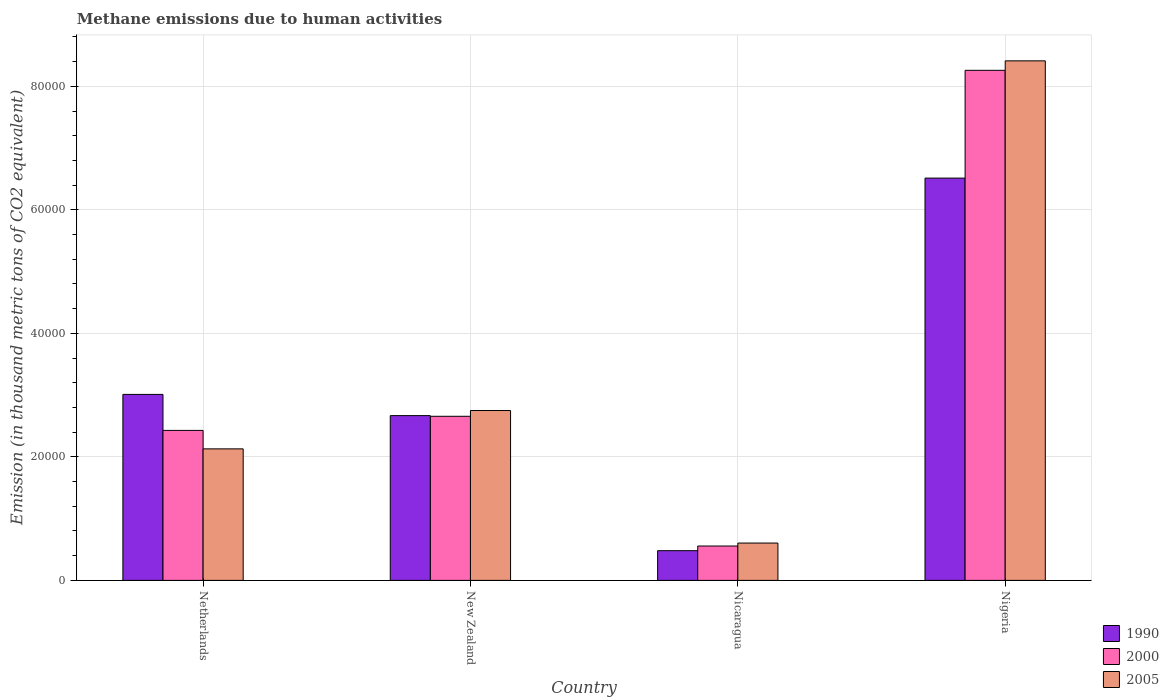How many different coloured bars are there?
Give a very brief answer. 3. What is the label of the 3rd group of bars from the left?
Your answer should be very brief. Nicaragua. What is the amount of methane emitted in 2000 in Nicaragua?
Your response must be concise. 5565.7. Across all countries, what is the maximum amount of methane emitted in 2005?
Provide a short and direct response. 8.41e+04. Across all countries, what is the minimum amount of methane emitted in 2000?
Ensure brevity in your answer.  5565.7. In which country was the amount of methane emitted in 2000 maximum?
Your response must be concise. Nigeria. In which country was the amount of methane emitted in 1990 minimum?
Offer a very short reply. Nicaragua. What is the total amount of methane emitted in 2000 in the graph?
Ensure brevity in your answer.  1.39e+05. What is the difference between the amount of methane emitted in 2000 in Netherlands and that in New Zealand?
Offer a very short reply. -2283.5. What is the difference between the amount of methane emitted in 2000 in Netherlands and the amount of methane emitted in 1990 in New Zealand?
Keep it short and to the point. -2394.1. What is the average amount of methane emitted in 1990 per country?
Your response must be concise. 3.17e+04. What is the difference between the amount of methane emitted of/in 2005 and amount of methane emitted of/in 1990 in New Zealand?
Provide a succinct answer. 824. What is the ratio of the amount of methane emitted in 2005 in New Zealand to that in Nigeria?
Provide a short and direct response. 0.33. Is the amount of methane emitted in 1990 in Netherlands less than that in New Zealand?
Your answer should be compact. No. What is the difference between the highest and the second highest amount of methane emitted in 1990?
Provide a succinct answer. -3.85e+04. What is the difference between the highest and the lowest amount of methane emitted in 2005?
Your answer should be very brief. 7.81e+04. In how many countries, is the amount of methane emitted in 2005 greater than the average amount of methane emitted in 2005 taken over all countries?
Your response must be concise. 1. Is the sum of the amount of methane emitted in 1990 in New Zealand and Nicaragua greater than the maximum amount of methane emitted in 2005 across all countries?
Your response must be concise. No. What does the 1st bar from the left in Nigeria represents?
Provide a succinct answer. 1990. Is it the case that in every country, the sum of the amount of methane emitted in 1990 and amount of methane emitted in 2000 is greater than the amount of methane emitted in 2005?
Ensure brevity in your answer.  Yes. How many bars are there?
Offer a very short reply. 12. How many countries are there in the graph?
Ensure brevity in your answer.  4. Does the graph contain any zero values?
Your response must be concise. No. Does the graph contain grids?
Ensure brevity in your answer.  Yes. How many legend labels are there?
Offer a terse response. 3. How are the legend labels stacked?
Give a very brief answer. Vertical. What is the title of the graph?
Ensure brevity in your answer.  Methane emissions due to human activities. What is the label or title of the Y-axis?
Ensure brevity in your answer.  Emission (in thousand metric tons of CO2 equivalent). What is the Emission (in thousand metric tons of CO2 equivalent) of 1990 in Netherlands?
Your answer should be compact. 3.01e+04. What is the Emission (in thousand metric tons of CO2 equivalent) of 2000 in Netherlands?
Give a very brief answer. 2.43e+04. What is the Emission (in thousand metric tons of CO2 equivalent) of 2005 in Netherlands?
Your answer should be compact. 2.13e+04. What is the Emission (in thousand metric tons of CO2 equivalent) in 1990 in New Zealand?
Provide a short and direct response. 2.67e+04. What is the Emission (in thousand metric tons of CO2 equivalent) of 2000 in New Zealand?
Ensure brevity in your answer.  2.66e+04. What is the Emission (in thousand metric tons of CO2 equivalent) in 2005 in New Zealand?
Keep it short and to the point. 2.75e+04. What is the Emission (in thousand metric tons of CO2 equivalent) in 1990 in Nicaragua?
Provide a short and direct response. 4811.3. What is the Emission (in thousand metric tons of CO2 equivalent) of 2000 in Nicaragua?
Your answer should be very brief. 5565.7. What is the Emission (in thousand metric tons of CO2 equivalent) in 2005 in Nicaragua?
Keep it short and to the point. 6045. What is the Emission (in thousand metric tons of CO2 equivalent) of 1990 in Nigeria?
Ensure brevity in your answer.  6.51e+04. What is the Emission (in thousand metric tons of CO2 equivalent) in 2000 in Nigeria?
Your response must be concise. 8.26e+04. What is the Emission (in thousand metric tons of CO2 equivalent) in 2005 in Nigeria?
Offer a very short reply. 8.41e+04. Across all countries, what is the maximum Emission (in thousand metric tons of CO2 equivalent) of 1990?
Provide a succinct answer. 6.51e+04. Across all countries, what is the maximum Emission (in thousand metric tons of CO2 equivalent) in 2000?
Keep it short and to the point. 8.26e+04. Across all countries, what is the maximum Emission (in thousand metric tons of CO2 equivalent) in 2005?
Make the answer very short. 8.41e+04. Across all countries, what is the minimum Emission (in thousand metric tons of CO2 equivalent) in 1990?
Provide a succinct answer. 4811.3. Across all countries, what is the minimum Emission (in thousand metric tons of CO2 equivalent) in 2000?
Provide a short and direct response. 5565.7. Across all countries, what is the minimum Emission (in thousand metric tons of CO2 equivalent) in 2005?
Ensure brevity in your answer.  6045. What is the total Emission (in thousand metric tons of CO2 equivalent) in 1990 in the graph?
Provide a short and direct response. 1.27e+05. What is the total Emission (in thousand metric tons of CO2 equivalent) of 2000 in the graph?
Ensure brevity in your answer.  1.39e+05. What is the total Emission (in thousand metric tons of CO2 equivalent) of 2005 in the graph?
Make the answer very short. 1.39e+05. What is the difference between the Emission (in thousand metric tons of CO2 equivalent) in 1990 in Netherlands and that in New Zealand?
Offer a terse response. 3434.2. What is the difference between the Emission (in thousand metric tons of CO2 equivalent) in 2000 in Netherlands and that in New Zealand?
Offer a very short reply. -2283.5. What is the difference between the Emission (in thousand metric tons of CO2 equivalent) in 2005 in Netherlands and that in New Zealand?
Your response must be concise. -6208.4. What is the difference between the Emission (in thousand metric tons of CO2 equivalent) of 1990 in Netherlands and that in Nicaragua?
Keep it short and to the point. 2.53e+04. What is the difference between the Emission (in thousand metric tons of CO2 equivalent) in 2000 in Netherlands and that in Nicaragua?
Give a very brief answer. 1.87e+04. What is the difference between the Emission (in thousand metric tons of CO2 equivalent) in 2005 in Netherlands and that in Nicaragua?
Provide a succinct answer. 1.53e+04. What is the difference between the Emission (in thousand metric tons of CO2 equivalent) in 1990 in Netherlands and that in Nigeria?
Your answer should be very brief. -3.50e+04. What is the difference between the Emission (in thousand metric tons of CO2 equivalent) of 2000 in Netherlands and that in Nigeria?
Your response must be concise. -5.83e+04. What is the difference between the Emission (in thousand metric tons of CO2 equivalent) of 2005 in Netherlands and that in Nigeria?
Offer a terse response. -6.28e+04. What is the difference between the Emission (in thousand metric tons of CO2 equivalent) in 1990 in New Zealand and that in Nicaragua?
Keep it short and to the point. 2.19e+04. What is the difference between the Emission (in thousand metric tons of CO2 equivalent) in 2000 in New Zealand and that in Nicaragua?
Offer a terse response. 2.10e+04. What is the difference between the Emission (in thousand metric tons of CO2 equivalent) of 2005 in New Zealand and that in Nicaragua?
Offer a very short reply. 2.15e+04. What is the difference between the Emission (in thousand metric tons of CO2 equivalent) of 1990 in New Zealand and that in Nigeria?
Give a very brief answer. -3.85e+04. What is the difference between the Emission (in thousand metric tons of CO2 equivalent) in 2000 in New Zealand and that in Nigeria?
Your answer should be compact. -5.60e+04. What is the difference between the Emission (in thousand metric tons of CO2 equivalent) of 2005 in New Zealand and that in Nigeria?
Offer a very short reply. -5.66e+04. What is the difference between the Emission (in thousand metric tons of CO2 equivalent) of 1990 in Nicaragua and that in Nigeria?
Your response must be concise. -6.03e+04. What is the difference between the Emission (in thousand metric tons of CO2 equivalent) of 2000 in Nicaragua and that in Nigeria?
Provide a succinct answer. -7.70e+04. What is the difference between the Emission (in thousand metric tons of CO2 equivalent) in 2005 in Nicaragua and that in Nigeria?
Offer a very short reply. -7.81e+04. What is the difference between the Emission (in thousand metric tons of CO2 equivalent) of 1990 in Netherlands and the Emission (in thousand metric tons of CO2 equivalent) of 2000 in New Zealand?
Ensure brevity in your answer.  3544.8. What is the difference between the Emission (in thousand metric tons of CO2 equivalent) of 1990 in Netherlands and the Emission (in thousand metric tons of CO2 equivalent) of 2005 in New Zealand?
Offer a very short reply. 2610.2. What is the difference between the Emission (in thousand metric tons of CO2 equivalent) of 2000 in Netherlands and the Emission (in thousand metric tons of CO2 equivalent) of 2005 in New Zealand?
Offer a very short reply. -3218.1. What is the difference between the Emission (in thousand metric tons of CO2 equivalent) of 1990 in Netherlands and the Emission (in thousand metric tons of CO2 equivalent) of 2000 in Nicaragua?
Your response must be concise. 2.45e+04. What is the difference between the Emission (in thousand metric tons of CO2 equivalent) in 1990 in Netherlands and the Emission (in thousand metric tons of CO2 equivalent) in 2005 in Nicaragua?
Your answer should be very brief. 2.41e+04. What is the difference between the Emission (in thousand metric tons of CO2 equivalent) of 2000 in Netherlands and the Emission (in thousand metric tons of CO2 equivalent) of 2005 in Nicaragua?
Offer a very short reply. 1.82e+04. What is the difference between the Emission (in thousand metric tons of CO2 equivalent) of 1990 in Netherlands and the Emission (in thousand metric tons of CO2 equivalent) of 2000 in Nigeria?
Provide a succinct answer. -5.25e+04. What is the difference between the Emission (in thousand metric tons of CO2 equivalent) of 1990 in Netherlands and the Emission (in thousand metric tons of CO2 equivalent) of 2005 in Nigeria?
Offer a terse response. -5.40e+04. What is the difference between the Emission (in thousand metric tons of CO2 equivalent) of 2000 in Netherlands and the Emission (in thousand metric tons of CO2 equivalent) of 2005 in Nigeria?
Make the answer very short. -5.98e+04. What is the difference between the Emission (in thousand metric tons of CO2 equivalent) in 1990 in New Zealand and the Emission (in thousand metric tons of CO2 equivalent) in 2000 in Nicaragua?
Ensure brevity in your answer.  2.11e+04. What is the difference between the Emission (in thousand metric tons of CO2 equivalent) of 1990 in New Zealand and the Emission (in thousand metric tons of CO2 equivalent) of 2005 in Nicaragua?
Provide a short and direct response. 2.06e+04. What is the difference between the Emission (in thousand metric tons of CO2 equivalent) in 2000 in New Zealand and the Emission (in thousand metric tons of CO2 equivalent) in 2005 in Nicaragua?
Keep it short and to the point. 2.05e+04. What is the difference between the Emission (in thousand metric tons of CO2 equivalent) in 1990 in New Zealand and the Emission (in thousand metric tons of CO2 equivalent) in 2000 in Nigeria?
Make the answer very short. -5.59e+04. What is the difference between the Emission (in thousand metric tons of CO2 equivalent) in 1990 in New Zealand and the Emission (in thousand metric tons of CO2 equivalent) in 2005 in Nigeria?
Your response must be concise. -5.74e+04. What is the difference between the Emission (in thousand metric tons of CO2 equivalent) of 2000 in New Zealand and the Emission (in thousand metric tons of CO2 equivalent) of 2005 in Nigeria?
Make the answer very short. -5.76e+04. What is the difference between the Emission (in thousand metric tons of CO2 equivalent) in 1990 in Nicaragua and the Emission (in thousand metric tons of CO2 equivalent) in 2000 in Nigeria?
Ensure brevity in your answer.  -7.78e+04. What is the difference between the Emission (in thousand metric tons of CO2 equivalent) of 1990 in Nicaragua and the Emission (in thousand metric tons of CO2 equivalent) of 2005 in Nigeria?
Your response must be concise. -7.93e+04. What is the difference between the Emission (in thousand metric tons of CO2 equivalent) of 2000 in Nicaragua and the Emission (in thousand metric tons of CO2 equivalent) of 2005 in Nigeria?
Give a very brief answer. -7.86e+04. What is the average Emission (in thousand metric tons of CO2 equivalent) in 1990 per country?
Your answer should be very brief. 3.17e+04. What is the average Emission (in thousand metric tons of CO2 equivalent) of 2000 per country?
Provide a short and direct response. 3.48e+04. What is the average Emission (in thousand metric tons of CO2 equivalent) in 2005 per country?
Make the answer very short. 3.47e+04. What is the difference between the Emission (in thousand metric tons of CO2 equivalent) of 1990 and Emission (in thousand metric tons of CO2 equivalent) of 2000 in Netherlands?
Ensure brevity in your answer.  5828.3. What is the difference between the Emission (in thousand metric tons of CO2 equivalent) in 1990 and Emission (in thousand metric tons of CO2 equivalent) in 2005 in Netherlands?
Your response must be concise. 8818.6. What is the difference between the Emission (in thousand metric tons of CO2 equivalent) in 2000 and Emission (in thousand metric tons of CO2 equivalent) in 2005 in Netherlands?
Provide a succinct answer. 2990.3. What is the difference between the Emission (in thousand metric tons of CO2 equivalent) in 1990 and Emission (in thousand metric tons of CO2 equivalent) in 2000 in New Zealand?
Offer a very short reply. 110.6. What is the difference between the Emission (in thousand metric tons of CO2 equivalent) in 1990 and Emission (in thousand metric tons of CO2 equivalent) in 2005 in New Zealand?
Provide a short and direct response. -824. What is the difference between the Emission (in thousand metric tons of CO2 equivalent) of 2000 and Emission (in thousand metric tons of CO2 equivalent) of 2005 in New Zealand?
Keep it short and to the point. -934.6. What is the difference between the Emission (in thousand metric tons of CO2 equivalent) of 1990 and Emission (in thousand metric tons of CO2 equivalent) of 2000 in Nicaragua?
Offer a terse response. -754.4. What is the difference between the Emission (in thousand metric tons of CO2 equivalent) of 1990 and Emission (in thousand metric tons of CO2 equivalent) of 2005 in Nicaragua?
Make the answer very short. -1233.7. What is the difference between the Emission (in thousand metric tons of CO2 equivalent) in 2000 and Emission (in thousand metric tons of CO2 equivalent) in 2005 in Nicaragua?
Make the answer very short. -479.3. What is the difference between the Emission (in thousand metric tons of CO2 equivalent) of 1990 and Emission (in thousand metric tons of CO2 equivalent) of 2000 in Nigeria?
Your answer should be compact. -1.75e+04. What is the difference between the Emission (in thousand metric tons of CO2 equivalent) in 1990 and Emission (in thousand metric tons of CO2 equivalent) in 2005 in Nigeria?
Ensure brevity in your answer.  -1.90e+04. What is the difference between the Emission (in thousand metric tons of CO2 equivalent) of 2000 and Emission (in thousand metric tons of CO2 equivalent) of 2005 in Nigeria?
Offer a terse response. -1533.6. What is the ratio of the Emission (in thousand metric tons of CO2 equivalent) of 1990 in Netherlands to that in New Zealand?
Make the answer very short. 1.13. What is the ratio of the Emission (in thousand metric tons of CO2 equivalent) of 2000 in Netherlands to that in New Zealand?
Make the answer very short. 0.91. What is the ratio of the Emission (in thousand metric tons of CO2 equivalent) of 2005 in Netherlands to that in New Zealand?
Your answer should be compact. 0.77. What is the ratio of the Emission (in thousand metric tons of CO2 equivalent) of 1990 in Netherlands to that in Nicaragua?
Offer a very short reply. 6.26. What is the ratio of the Emission (in thousand metric tons of CO2 equivalent) of 2000 in Netherlands to that in Nicaragua?
Provide a short and direct response. 4.36. What is the ratio of the Emission (in thousand metric tons of CO2 equivalent) of 2005 in Netherlands to that in Nicaragua?
Provide a succinct answer. 3.52. What is the ratio of the Emission (in thousand metric tons of CO2 equivalent) in 1990 in Netherlands to that in Nigeria?
Offer a very short reply. 0.46. What is the ratio of the Emission (in thousand metric tons of CO2 equivalent) in 2000 in Netherlands to that in Nigeria?
Your response must be concise. 0.29. What is the ratio of the Emission (in thousand metric tons of CO2 equivalent) of 2005 in Netherlands to that in Nigeria?
Your response must be concise. 0.25. What is the ratio of the Emission (in thousand metric tons of CO2 equivalent) in 1990 in New Zealand to that in Nicaragua?
Make the answer very short. 5.55. What is the ratio of the Emission (in thousand metric tons of CO2 equivalent) of 2000 in New Zealand to that in Nicaragua?
Keep it short and to the point. 4.77. What is the ratio of the Emission (in thousand metric tons of CO2 equivalent) in 2005 in New Zealand to that in Nicaragua?
Keep it short and to the point. 4.55. What is the ratio of the Emission (in thousand metric tons of CO2 equivalent) of 1990 in New Zealand to that in Nigeria?
Your answer should be compact. 0.41. What is the ratio of the Emission (in thousand metric tons of CO2 equivalent) in 2000 in New Zealand to that in Nigeria?
Your response must be concise. 0.32. What is the ratio of the Emission (in thousand metric tons of CO2 equivalent) of 2005 in New Zealand to that in Nigeria?
Ensure brevity in your answer.  0.33. What is the ratio of the Emission (in thousand metric tons of CO2 equivalent) of 1990 in Nicaragua to that in Nigeria?
Keep it short and to the point. 0.07. What is the ratio of the Emission (in thousand metric tons of CO2 equivalent) in 2000 in Nicaragua to that in Nigeria?
Your answer should be very brief. 0.07. What is the ratio of the Emission (in thousand metric tons of CO2 equivalent) in 2005 in Nicaragua to that in Nigeria?
Make the answer very short. 0.07. What is the difference between the highest and the second highest Emission (in thousand metric tons of CO2 equivalent) in 1990?
Offer a very short reply. 3.50e+04. What is the difference between the highest and the second highest Emission (in thousand metric tons of CO2 equivalent) in 2000?
Ensure brevity in your answer.  5.60e+04. What is the difference between the highest and the second highest Emission (in thousand metric tons of CO2 equivalent) of 2005?
Your answer should be compact. 5.66e+04. What is the difference between the highest and the lowest Emission (in thousand metric tons of CO2 equivalent) in 1990?
Offer a terse response. 6.03e+04. What is the difference between the highest and the lowest Emission (in thousand metric tons of CO2 equivalent) in 2000?
Your answer should be very brief. 7.70e+04. What is the difference between the highest and the lowest Emission (in thousand metric tons of CO2 equivalent) in 2005?
Ensure brevity in your answer.  7.81e+04. 